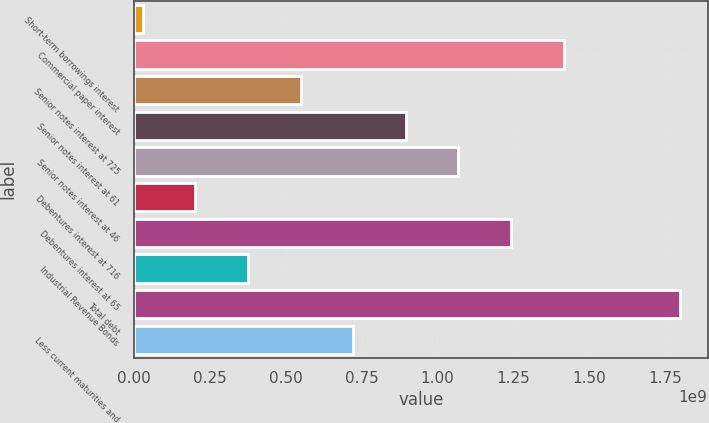Convert chart to OTSL. <chart><loc_0><loc_0><loc_500><loc_500><bar_chart><fcel>Short-term borrowings interest<fcel>Commercial paper interest<fcel>Senior notes interest at 725<fcel>Senior notes interest at 61<fcel>Senior notes interest at 46<fcel>Debentures interest at 716<fcel>Debentures interest at 65<fcel>Industrial Revenue Bonds<fcel>Total debt<fcel>Less current maturities and<nl><fcel>2.93e+07<fcel>1.41601e+09<fcel>5.49318e+08<fcel>8.95996e+08<fcel>1.06934e+09<fcel>2.02639e+08<fcel>1.24267e+09<fcel>3.75978e+08<fcel>1.80047e+09<fcel>7.22657e+08<nl></chart> 